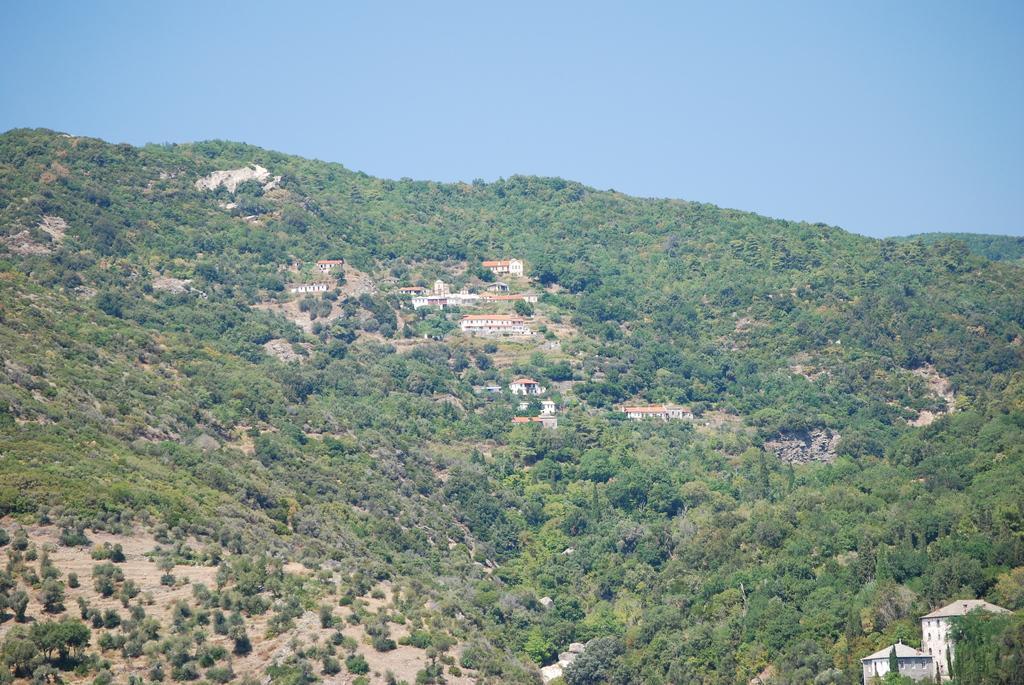Describe this image in one or two sentences. In this image I can see the ground, few trees, few buildings which are white and orange in color and in the background I can see the sky. 